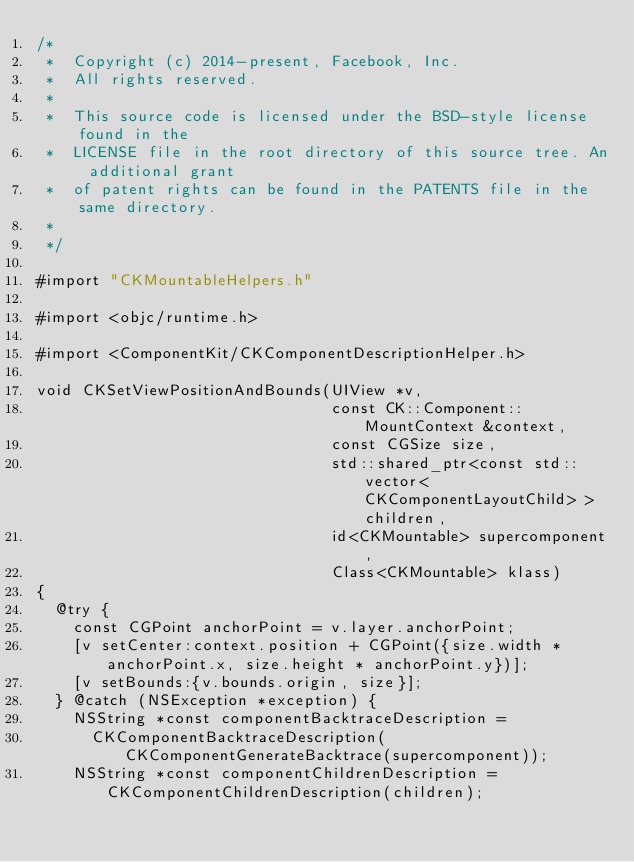Convert code to text. <code><loc_0><loc_0><loc_500><loc_500><_ObjectiveC_>/*
 *  Copyright (c) 2014-present, Facebook, Inc.
 *  All rights reserved.
 *
 *  This source code is licensed under the BSD-style license found in the
 *  LICENSE file in the root directory of this source tree. An additional grant
 *  of patent rights can be found in the PATENTS file in the same directory.
 *
 */

#import "CKMountableHelpers.h"

#import <objc/runtime.h>

#import <ComponentKit/CKComponentDescriptionHelper.h>

void CKSetViewPositionAndBounds(UIView *v,
                                const CK::Component::MountContext &context,
                                const CGSize size,
                                std::shared_ptr<const std::vector<CKComponentLayoutChild> > children,
                                id<CKMountable> supercomponent,
                                Class<CKMountable> klass)
{
  @try {
    const CGPoint anchorPoint = v.layer.anchorPoint;
    [v setCenter:context.position + CGPoint({size.width * anchorPoint.x, size.height * anchorPoint.y})];
    [v setBounds:{v.bounds.origin, size}];
  } @catch (NSException *exception) {
    NSString *const componentBacktraceDescription =
      CKComponentBacktraceDescription(CKComponentGenerateBacktrace(supercomponent));
    NSString *const componentChildrenDescription = CKComponentChildrenDescription(children);</code> 